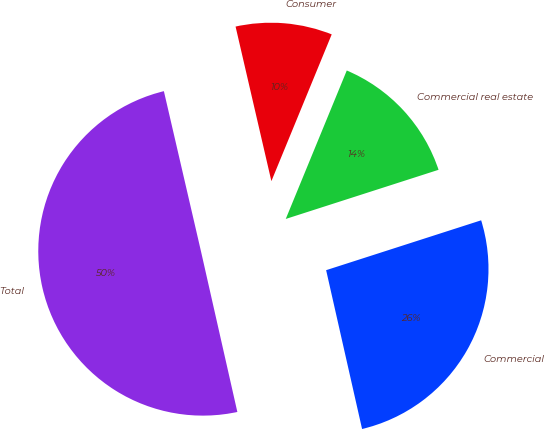Convert chart. <chart><loc_0><loc_0><loc_500><loc_500><pie_chart><fcel>Commercial<fcel>Commercial real estate<fcel>Consumer<fcel>Total<nl><fcel>26.41%<fcel>13.84%<fcel>9.83%<fcel>49.92%<nl></chart> 